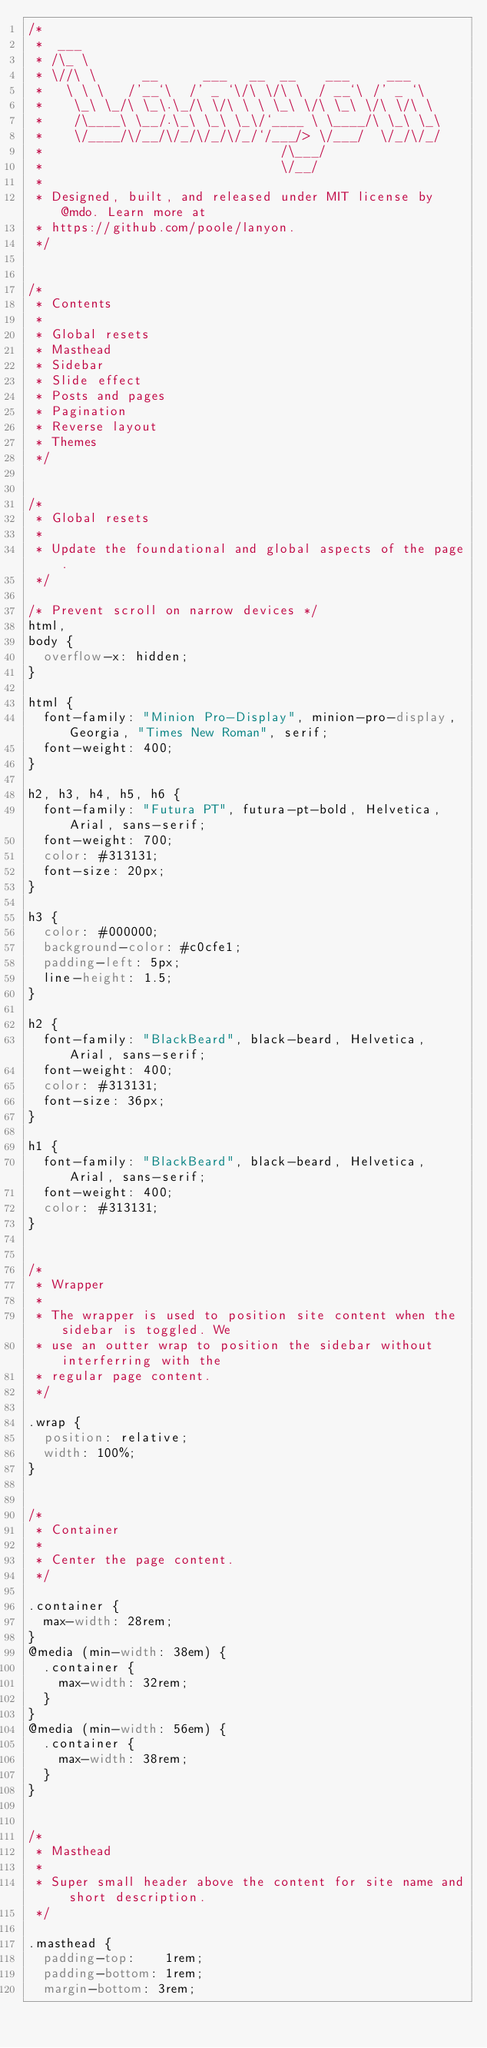<code> <loc_0><loc_0><loc_500><loc_500><_CSS_>/*
 *  ___
 * /\_ \
 * \//\ \      __      ___   __  __    ___     ___
 *   \ \ \   /'__`\  /' _ `\/\ \/\ \  / __`\ /' _ `\
 *    \_\ \_/\ \_\.\_/\ \/\ \ \ \_\ \/\ \_\ \/\ \/\ \
 *    /\____\ \__/.\_\ \_\ \_\/`____ \ \____/\ \_\ \_\
 *    \/____/\/__/\/_/\/_/\/_/`/___/> \/___/  \/_/\/_/
 *                               /\___/
 *                               \/__/
 *
 * Designed, built, and released under MIT license by @mdo. Learn more at
 * https://github.com/poole/lanyon.
 */


/*
 * Contents
 *
 * Global resets
 * Masthead
 * Sidebar
 * Slide effect
 * Posts and pages
 * Pagination
 * Reverse layout
 * Themes
 */


/*
 * Global resets
 *
 * Update the foundational and global aspects of the page.
 */

/* Prevent scroll on narrow devices */
html,
body {
  overflow-x: hidden;
}

html {
  font-family: "Minion Pro-Display", minion-pro-display, Georgia, "Times New Roman", serif;
  font-weight: 400;
}

h2, h3, h4, h5, h6 {
  font-family: "Futura PT", futura-pt-bold, Helvetica, Arial, sans-serif;
  font-weight: 700;
  color: #313131;
  font-size: 20px;
}

h3 {
  color: #000000;
  background-color: #c0cfe1;
  padding-left: 5px;
  line-height: 1.5;
}

h2 {
  font-family: "BlackBeard", black-beard, Helvetica, Arial, sans-serif;
  font-weight: 400;
  color: #313131;
  font-size: 36px;
}

h1 {
  font-family: "BlackBeard", black-beard, Helvetica, Arial, sans-serif;
  font-weight: 400;
  color: #313131;
}


/*
 * Wrapper
 *
 * The wrapper is used to position site content when the sidebar is toggled. We
 * use an outter wrap to position the sidebar without interferring with the
 * regular page content.
 */

.wrap {
  position: relative;
  width: 100%;
}


/*
 * Container
 *
 * Center the page content.
 */

.container {
  max-width: 28rem;
}
@media (min-width: 38em) {
  .container {
    max-width: 32rem;
  }
}
@media (min-width: 56em) {
  .container {
    max-width: 38rem;
  }
}


/*
 * Masthead
 *
 * Super small header above the content for site name and short description.
 */

.masthead {
  padding-top:    1rem;
  padding-bottom: 1rem;
  margin-bottom: 3rem;</code> 